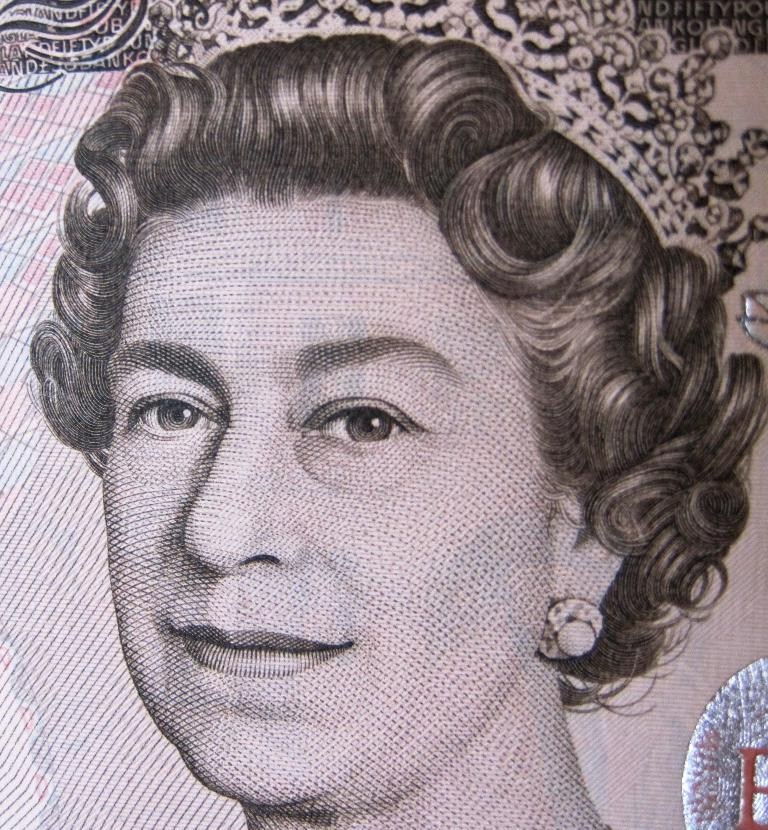What is the main subject of the image? There is a drawing in the image. What can be seen in the drawing? There is a woman in the center of the drawing. What type of farm animals can be seen in the drawing? There are no farm animals present in the drawing; it features a woman in the center. What type of destruction is depicted in the drawing? There is no destruction depicted in the drawing; it features a woman in the center. 